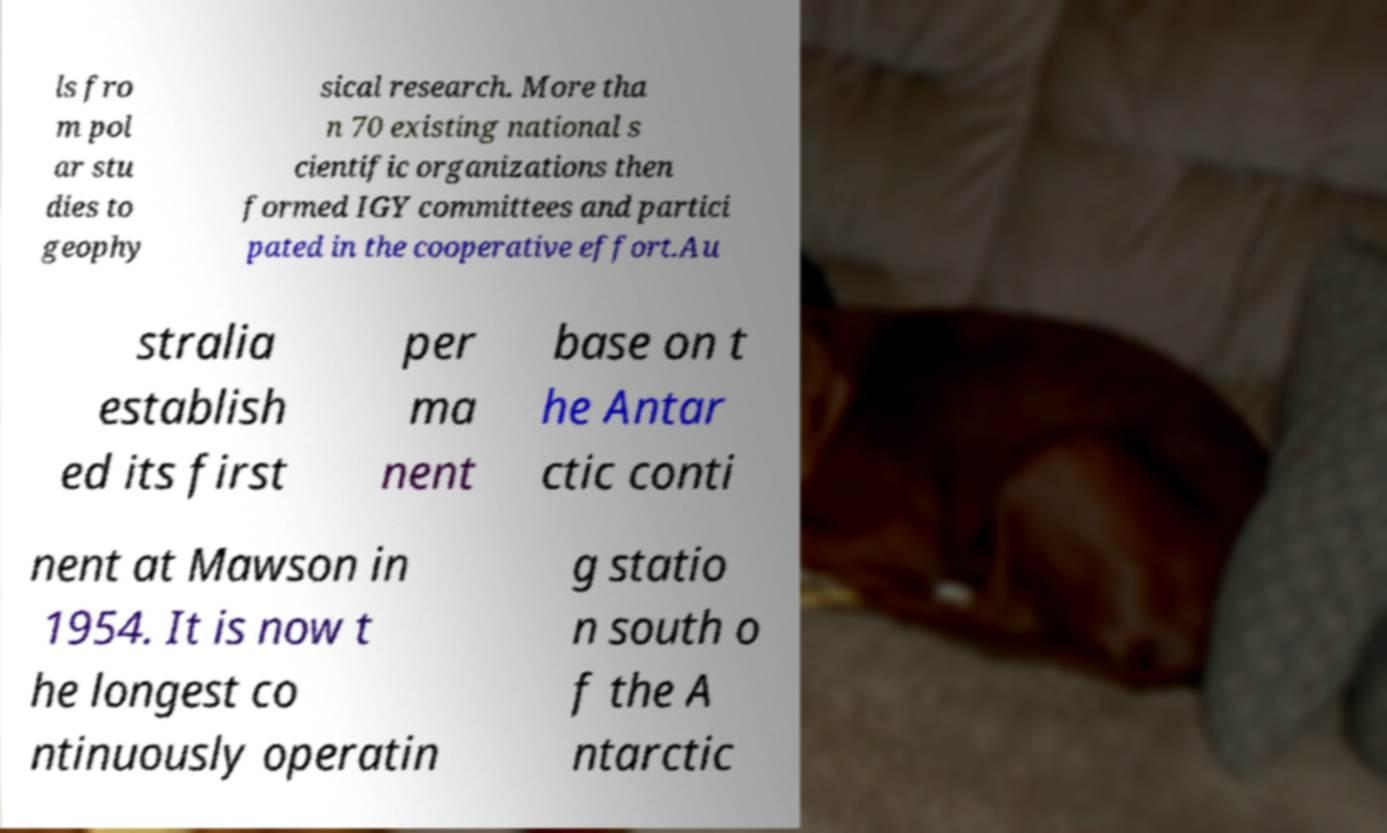Please identify and transcribe the text found in this image. ls fro m pol ar stu dies to geophy sical research. More tha n 70 existing national s cientific organizations then formed IGY committees and partici pated in the cooperative effort.Au stralia establish ed its first per ma nent base on t he Antar ctic conti nent at Mawson in 1954. It is now t he longest co ntinuously operatin g statio n south o f the A ntarctic 